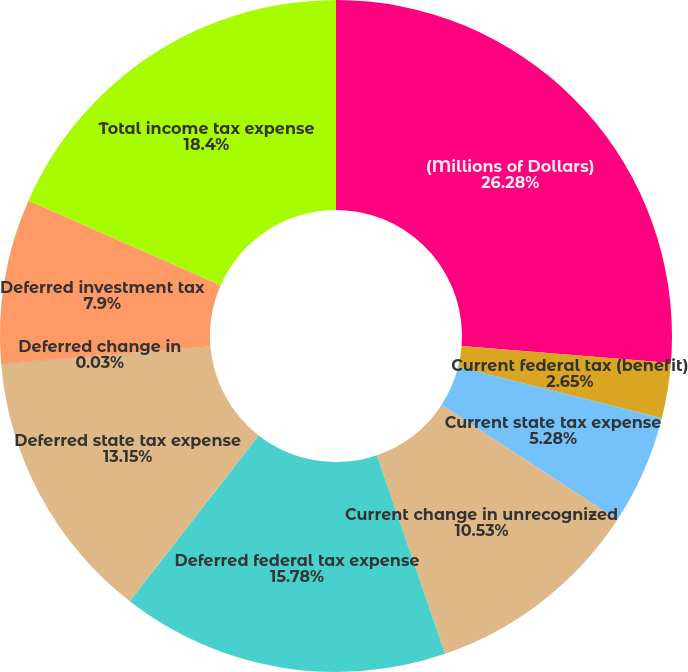Convert chart to OTSL. <chart><loc_0><loc_0><loc_500><loc_500><pie_chart><fcel>(Millions of Dollars)<fcel>Current federal tax (benefit)<fcel>Current state tax expense<fcel>Current change in unrecognized<fcel>Deferred federal tax expense<fcel>Deferred state tax expense<fcel>Deferred change in<fcel>Deferred investment tax<fcel>Total income tax expense<nl><fcel>26.28%<fcel>2.65%<fcel>5.28%<fcel>10.53%<fcel>15.78%<fcel>13.15%<fcel>0.03%<fcel>7.9%<fcel>18.4%<nl></chart> 